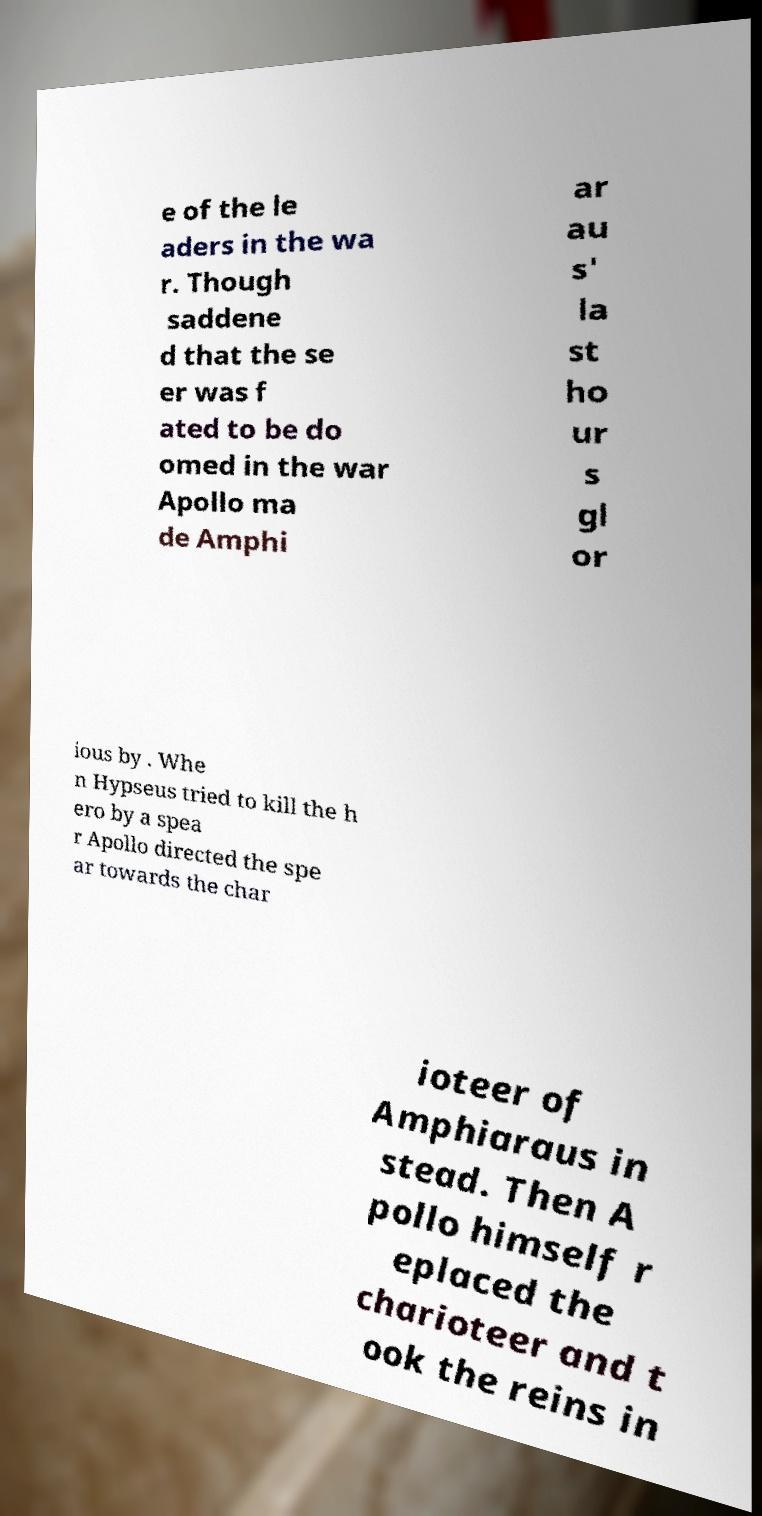Could you extract and type out the text from this image? e of the le aders in the wa r. Though saddene d that the se er was f ated to be do omed in the war Apollo ma de Amphi ar au s' la st ho ur s gl or ious by . Whe n Hypseus tried to kill the h ero by a spea r Apollo directed the spe ar towards the char ioteer of Amphiaraus in stead. Then A pollo himself r eplaced the charioteer and t ook the reins in 